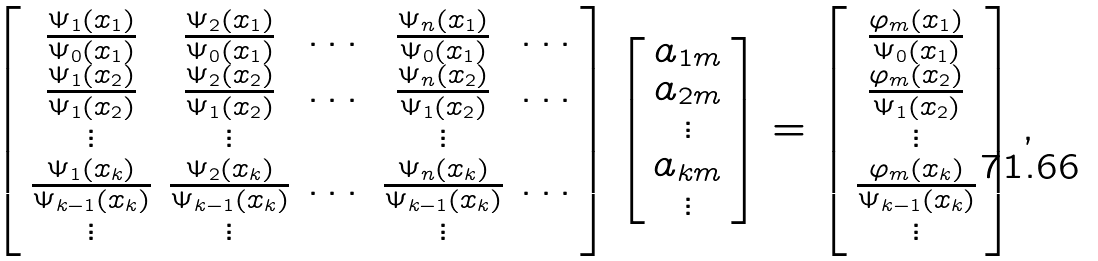<formula> <loc_0><loc_0><loc_500><loc_500>\left [ \begin{array} { c c c c c } \frac { \Psi _ { 1 } ( x _ { 1 } ) } { \Psi _ { 0 } ( x _ { 1 } ) } & \frac { \Psi _ { 2 } ( x _ { 1 } ) } { \Psi _ { 0 } ( x _ { 1 } ) } & \dots & \frac { \Psi _ { n } ( x _ { 1 } ) } { \Psi _ { 0 } ( x _ { 1 } ) } & \dots \\ \frac { \Psi _ { 1 } ( x _ { 2 } ) } { \Psi _ { 1 } ( x _ { 2 } ) } & \frac { \Psi _ { 2 } ( x _ { 2 } ) } { \Psi _ { 1 } ( x _ { 2 } ) } & \dots & \frac { \Psi _ { n } ( x _ { 2 } ) } { \Psi _ { 1 } ( x _ { 2 } ) } & \dots \\ \vdots & \vdots & & \vdots & \\ \frac { \Psi _ { 1 } ( x _ { k } ) } { \Psi _ { k - 1 } ( x _ { k } ) } & \frac { \Psi _ { 2 } ( x _ { k } ) } { \Psi _ { k - 1 } ( x _ { k } ) } & \dots & \frac { \Psi _ { n } ( x _ { k } ) } { \Psi _ { k - 1 } ( x _ { k } ) } & \dots \\ \vdots & \vdots & & \vdots & \end{array} \right ] \left [ \begin{array} { c } a _ { 1 m } \\ a _ { 2 m } \\ \vdots \\ a _ { k m } \\ \vdots \end{array} \right ] = \left [ \begin{array} { c } \frac { \varphi _ { m } ( x _ { 1 } ) } { \Psi _ { 0 } ( x _ { 1 } ) } \\ \frac { \varphi _ { m } ( x _ { 2 } ) } { \Psi _ { 1 } ( x _ { 2 } ) } \\ \vdots \\ \frac { \varphi _ { m } ( x _ { k } ) } { \Psi _ { k - 1 } ( x _ { k } ) } \\ \vdots \end{array} \right ] ,</formula> 